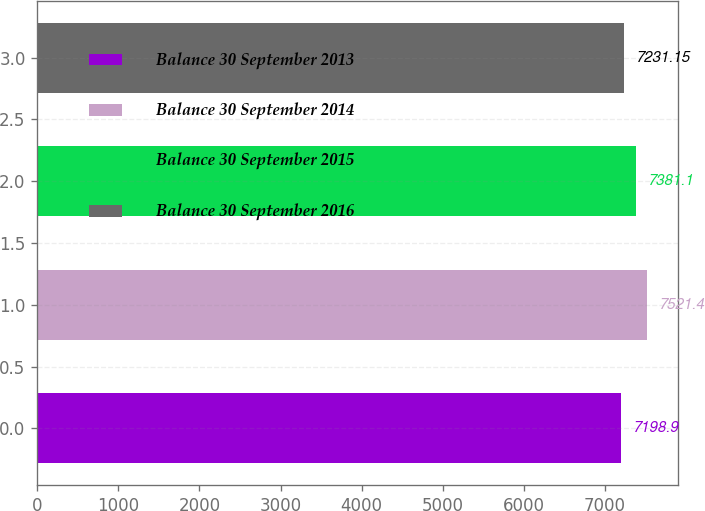<chart> <loc_0><loc_0><loc_500><loc_500><bar_chart><fcel>Balance 30 September 2013<fcel>Balance 30 September 2014<fcel>Balance 30 September 2015<fcel>Balance 30 September 2016<nl><fcel>7198.9<fcel>7521.4<fcel>7381.1<fcel>7231.15<nl></chart> 